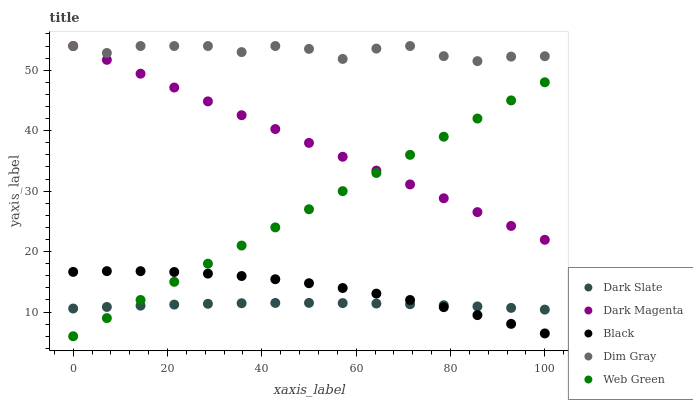Does Dark Slate have the minimum area under the curve?
Answer yes or no. Yes. Does Dim Gray have the maximum area under the curve?
Answer yes or no. Yes. Does Black have the minimum area under the curve?
Answer yes or no. No. Does Black have the maximum area under the curve?
Answer yes or no. No. Is Web Green the smoothest?
Answer yes or no. Yes. Is Dim Gray the roughest?
Answer yes or no. Yes. Is Black the smoothest?
Answer yes or no. No. Is Black the roughest?
Answer yes or no. No. Does Web Green have the lowest value?
Answer yes or no. Yes. Does Black have the lowest value?
Answer yes or no. No. Does Dark Magenta have the highest value?
Answer yes or no. Yes. Does Black have the highest value?
Answer yes or no. No. Is Black less than Dark Magenta?
Answer yes or no. Yes. Is Dim Gray greater than Web Green?
Answer yes or no. Yes. Does Web Green intersect Dark Magenta?
Answer yes or no. Yes. Is Web Green less than Dark Magenta?
Answer yes or no. No. Is Web Green greater than Dark Magenta?
Answer yes or no. No. Does Black intersect Dark Magenta?
Answer yes or no. No. 